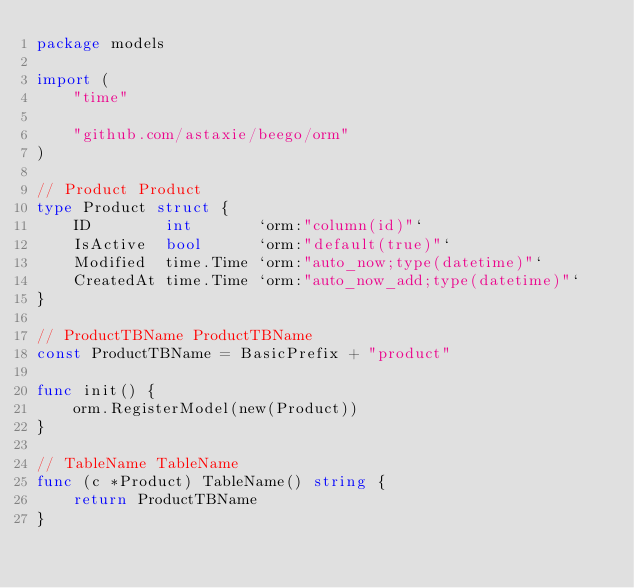<code> <loc_0><loc_0><loc_500><loc_500><_Go_>package models

import (
	"time"

	"github.com/astaxie/beego/orm"
)

// Product Product
type Product struct {
	ID        int       `orm:"column(id)"`
	IsActive  bool      `orm:"default(true)"`
	Modified  time.Time `orm:"auto_now;type(datetime)"`
	CreatedAt time.Time `orm:"auto_now_add;type(datetime)"`
}

// ProductTBName ProductTBName
const ProductTBName = BasicPrefix + "product"

func init() {
	orm.RegisterModel(new(Product))
}

// TableName TableName
func (c *Product) TableName() string {
	return ProductTBName
}
</code> 